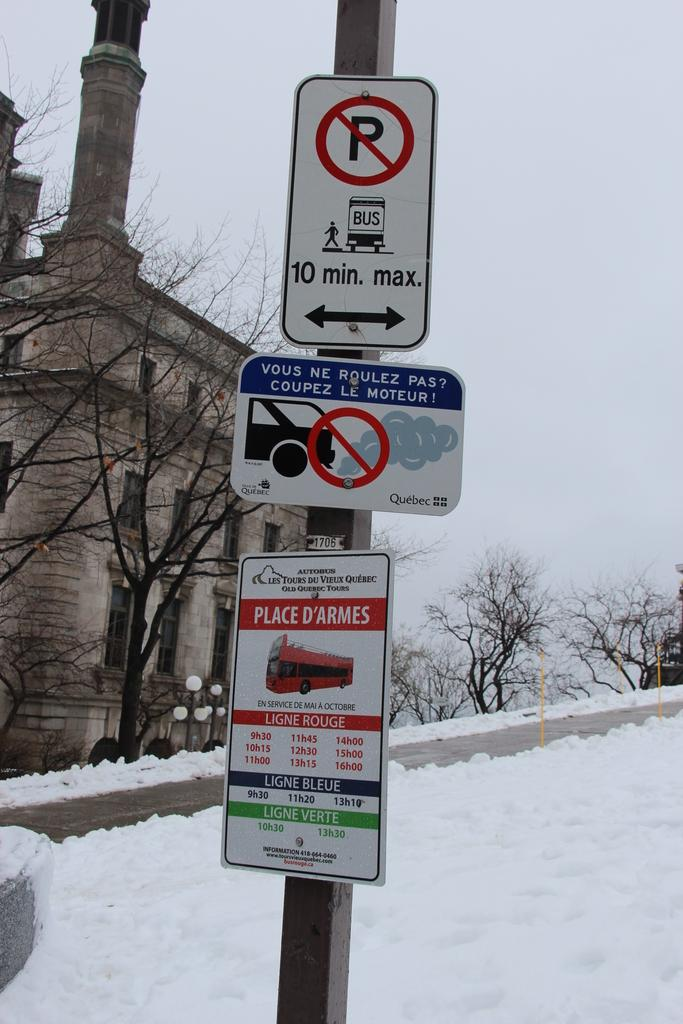Provide a one-sentence caption for the provided image. Three signs are on a sign pole with the top sign indicating no parking, 10 minute max. 